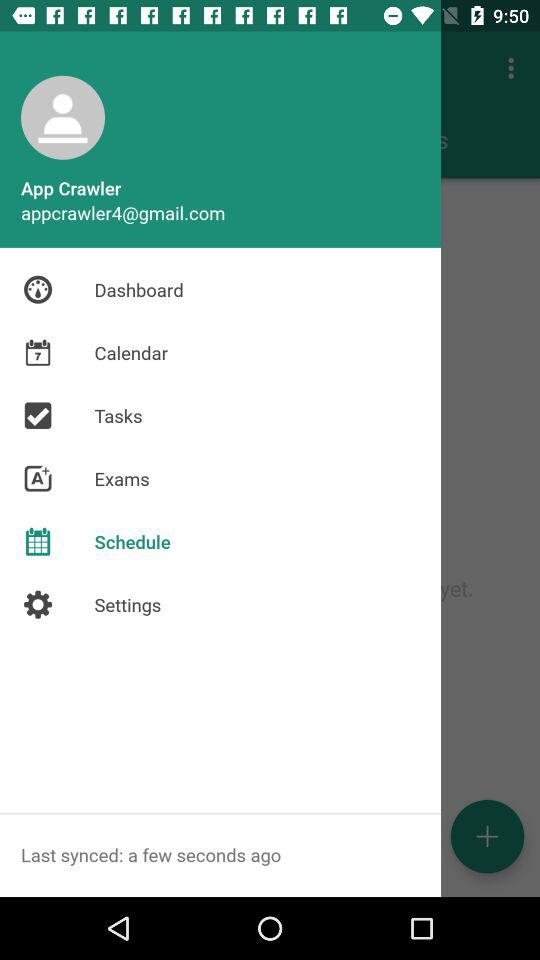Which item is selected? The selected item is "Schedule". 